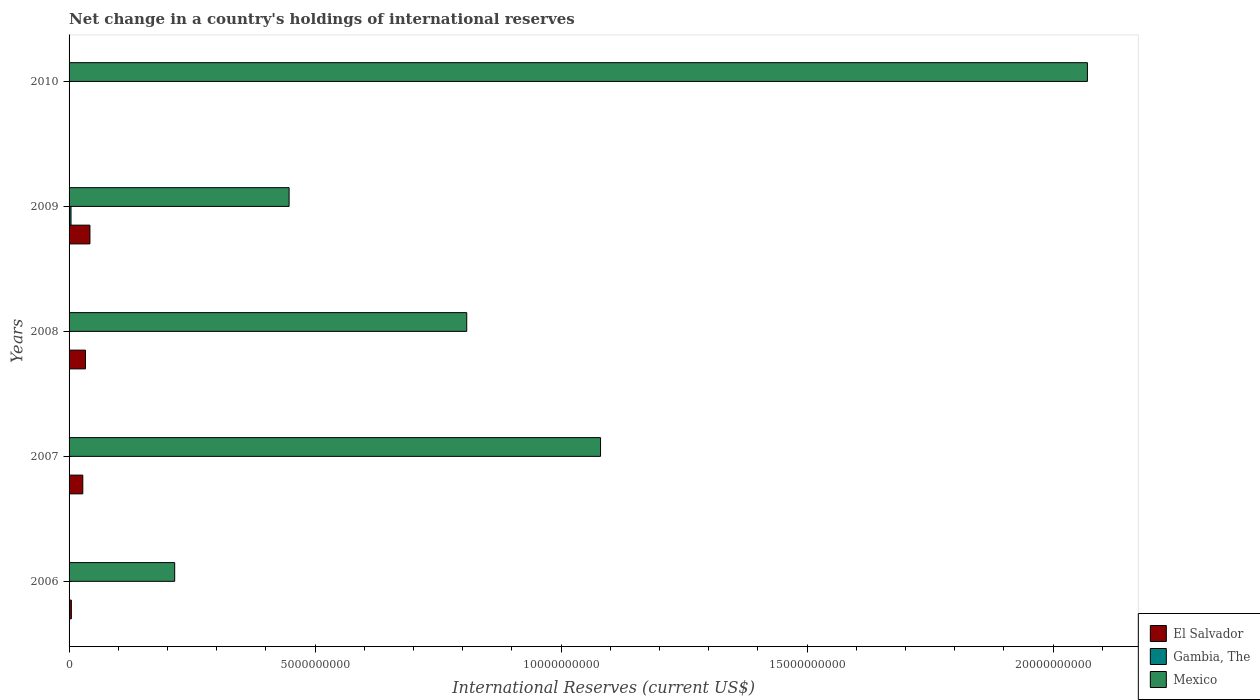Are the number of bars per tick equal to the number of legend labels?
Provide a short and direct response. No. What is the label of the 3rd group of bars from the top?
Ensure brevity in your answer.  2008. In how many cases, is the number of bars for a given year not equal to the number of legend labels?
Offer a terse response. 3. What is the international reserves in El Salvador in 2009?
Your response must be concise. 4.24e+08. Across all years, what is the maximum international reserves in El Salvador?
Your response must be concise. 4.24e+08. What is the total international reserves in Gambia, The in the graph?
Ensure brevity in your answer.  4.07e+07. What is the difference between the international reserves in Mexico in 2008 and that in 2009?
Ensure brevity in your answer.  3.61e+09. What is the difference between the international reserves in Mexico in 2010 and the international reserves in Gambia, The in 2009?
Give a very brief answer. 2.07e+1. What is the average international reserves in Mexico per year?
Offer a very short reply. 9.24e+09. In the year 2006, what is the difference between the international reserves in Gambia, The and international reserves in Mexico?
Provide a succinct answer. -2.15e+09. Is the international reserves in El Salvador in 2008 less than that in 2009?
Provide a succinct answer. Yes. What is the difference between the highest and the second highest international reserves in El Salvador?
Offer a very short reply. 9.07e+07. What is the difference between the highest and the lowest international reserves in El Salvador?
Offer a very short reply. 4.24e+08. Is the sum of the international reserves in Gambia, The in 2006 and 2009 greater than the maximum international reserves in Mexico across all years?
Ensure brevity in your answer.  No. Are all the bars in the graph horizontal?
Offer a very short reply. Yes. What is the difference between two consecutive major ticks on the X-axis?
Your answer should be very brief. 5.00e+09. Are the values on the major ticks of X-axis written in scientific E-notation?
Your answer should be very brief. No. Where does the legend appear in the graph?
Your answer should be very brief. Bottom right. What is the title of the graph?
Give a very brief answer. Net change in a country's holdings of international reserves. What is the label or title of the X-axis?
Your answer should be compact. International Reserves (current US$). What is the label or title of the Y-axis?
Your response must be concise. Years. What is the International Reserves (current US$) of El Salvador in 2006?
Provide a succinct answer. 4.66e+07. What is the International Reserves (current US$) in Gambia, The in 2006?
Your answer should be compact. 1.14e+06. What is the International Reserves (current US$) in Mexico in 2006?
Provide a succinct answer. 2.15e+09. What is the International Reserves (current US$) in El Salvador in 2007?
Offer a terse response. 2.79e+08. What is the International Reserves (current US$) in Gambia, The in 2007?
Provide a short and direct response. 0. What is the International Reserves (current US$) in Mexico in 2007?
Ensure brevity in your answer.  1.08e+1. What is the International Reserves (current US$) in El Salvador in 2008?
Keep it short and to the point. 3.33e+08. What is the International Reserves (current US$) of Gambia, The in 2008?
Your answer should be very brief. 0. What is the International Reserves (current US$) in Mexico in 2008?
Give a very brief answer. 8.08e+09. What is the International Reserves (current US$) in El Salvador in 2009?
Offer a very short reply. 4.24e+08. What is the International Reserves (current US$) of Gambia, The in 2009?
Offer a very short reply. 3.96e+07. What is the International Reserves (current US$) in Mexico in 2009?
Your answer should be compact. 4.47e+09. What is the International Reserves (current US$) of Gambia, The in 2010?
Give a very brief answer. 0. What is the International Reserves (current US$) in Mexico in 2010?
Keep it short and to the point. 2.07e+1. Across all years, what is the maximum International Reserves (current US$) of El Salvador?
Ensure brevity in your answer.  4.24e+08. Across all years, what is the maximum International Reserves (current US$) in Gambia, The?
Your answer should be compact. 3.96e+07. Across all years, what is the maximum International Reserves (current US$) of Mexico?
Provide a succinct answer. 2.07e+1. Across all years, what is the minimum International Reserves (current US$) of El Salvador?
Provide a succinct answer. 0. Across all years, what is the minimum International Reserves (current US$) of Gambia, The?
Ensure brevity in your answer.  0. Across all years, what is the minimum International Reserves (current US$) of Mexico?
Your answer should be very brief. 2.15e+09. What is the total International Reserves (current US$) in El Salvador in the graph?
Your answer should be very brief. 1.08e+09. What is the total International Reserves (current US$) in Gambia, The in the graph?
Provide a succinct answer. 4.07e+07. What is the total International Reserves (current US$) of Mexico in the graph?
Make the answer very short. 4.62e+1. What is the difference between the International Reserves (current US$) in El Salvador in 2006 and that in 2007?
Provide a short and direct response. -2.32e+08. What is the difference between the International Reserves (current US$) in Mexico in 2006 and that in 2007?
Provide a short and direct response. -8.66e+09. What is the difference between the International Reserves (current US$) of El Salvador in 2006 and that in 2008?
Give a very brief answer. -2.87e+08. What is the difference between the International Reserves (current US$) of Mexico in 2006 and that in 2008?
Your answer should be very brief. -5.94e+09. What is the difference between the International Reserves (current US$) of El Salvador in 2006 and that in 2009?
Keep it short and to the point. -3.78e+08. What is the difference between the International Reserves (current US$) of Gambia, The in 2006 and that in 2009?
Ensure brevity in your answer.  -3.85e+07. What is the difference between the International Reserves (current US$) in Mexico in 2006 and that in 2009?
Provide a succinct answer. -2.33e+09. What is the difference between the International Reserves (current US$) in Mexico in 2006 and that in 2010?
Offer a terse response. -1.86e+1. What is the difference between the International Reserves (current US$) in El Salvador in 2007 and that in 2008?
Your answer should be very brief. -5.45e+07. What is the difference between the International Reserves (current US$) of Mexico in 2007 and that in 2008?
Provide a short and direct response. 2.72e+09. What is the difference between the International Reserves (current US$) of El Salvador in 2007 and that in 2009?
Provide a short and direct response. -1.45e+08. What is the difference between the International Reserves (current US$) in Mexico in 2007 and that in 2009?
Keep it short and to the point. 6.33e+09. What is the difference between the International Reserves (current US$) of Mexico in 2007 and that in 2010?
Ensure brevity in your answer.  -9.90e+09. What is the difference between the International Reserves (current US$) of El Salvador in 2008 and that in 2009?
Ensure brevity in your answer.  -9.07e+07. What is the difference between the International Reserves (current US$) in Mexico in 2008 and that in 2009?
Your response must be concise. 3.61e+09. What is the difference between the International Reserves (current US$) in Mexico in 2008 and that in 2010?
Offer a terse response. -1.26e+1. What is the difference between the International Reserves (current US$) of Mexico in 2009 and that in 2010?
Your response must be concise. -1.62e+1. What is the difference between the International Reserves (current US$) in El Salvador in 2006 and the International Reserves (current US$) in Mexico in 2007?
Your answer should be compact. -1.08e+1. What is the difference between the International Reserves (current US$) in Gambia, The in 2006 and the International Reserves (current US$) in Mexico in 2007?
Your response must be concise. -1.08e+1. What is the difference between the International Reserves (current US$) of El Salvador in 2006 and the International Reserves (current US$) of Mexico in 2008?
Your answer should be very brief. -8.04e+09. What is the difference between the International Reserves (current US$) of Gambia, The in 2006 and the International Reserves (current US$) of Mexico in 2008?
Ensure brevity in your answer.  -8.08e+09. What is the difference between the International Reserves (current US$) in El Salvador in 2006 and the International Reserves (current US$) in Gambia, The in 2009?
Give a very brief answer. 7.02e+06. What is the difference between the International Reserves (current US$) in El Salvador in 2006 and the International Reserves (current US$) in Mexico in 2009?
Keep it short and to the point. -4.43e+09. What is the difference between the International Reserves (current US$) in Gambia, The in 2006 and the International Reserves (current US$) in Mexico in 2009?
Give a very brief answer. -4.47e+09. What is the difference between the International Reserves (current US$) in El Salvador in 2006 and the International Reserves (current US$) in Mexico in 2010?
Give a very brief answer. -2.07e+1. What is the difference between the International Reserves (current US$) in Gambia, The in 2006 and the International Reserves (current US$) in Mexico in 2010?
Your response must be concise. -2.07e+1. What is the difference between the International Reserves (current US$) of El Salvador in 2007 and the International Reserves (current US$) of Mexico in 2008?
Offer a terse response. -7.80e+09. What is the difference between the International Reserves (current US$) in El Salvador in 2007 and the International Reserves (current US$) in Gambia, The in 2009?
Ensure brevity in your answer.  2.39e+08. What is the difference between the International Reserves (current US$) of El Salvador in 2007 and the International Reserves (current US$) of Mexico in 2009?
Ensure brevity in your answer.  -4.19e+09. What is the difference between the International Reserves (current US$) of El Salvador in 2007 and the International Reserves (current US$) of Mexico in 2010?
Keep it short and to the point. -2.04e+1. What is the difference between the International Reserves (current US$) of El Salvador in 2008 and the International Reserves (current US$) of Gambia, The in 2009?
Your answer should be very brief. 2.94e+08. What is the difference between the International Reserves (current US$) of El Salvador in 2008 and the International Reserves (current US$) of Mexico in 2009?
Your answer should be very brief. -4.14e+09. What is the difference between the International Reserves (current US$) of El Salvador in 2008 and the International Reserves (current US$) of Mexico in 2010?
Keep it short and to the point. -2.04e+1. What is the difference between the International Reserves (current US$) in El Salvador in 2009 and the International Reserves (current US$) in Mexico in 2010?
Provide a short and direct response. -2.03e+1. What is the difference between the International Reserves (current US$) in Gambia, The in 2009 and the International Reserves (current US$) in Mexico in 2010?
Your response must be concise. -2.07e+1. What is the average International Reserves (current US$) in El Salvador per year?
Offer a terse response. 2.17e+08. What is the average International Reserves (current US$) in Gambia, The per year?
Provide a succinct answer. 8.15e+06. What is the average International Reserves (current US$) in Mexico per year?
Make the answer very short. 9.24e+09. In the year 2006, what is the difference between the International Reserves (current US$) in El Salvador and International Reserves (current US$) in Gambia, The?
Make the answer very short. 4.55e+07. In the year 2006, what is the difference between the International Reserves (current US$) of El Salvador and International Reserves (current US$) of Mexico?
Your answer should be compact. -2.10e+09. In the year 2006, what is the difference between the International Reserves (current US$) in Gambia, The and International Reserves (current US$) in Mexico?
Give a very brief answer. -2.15e+09. In the year 2007, what is the difference between the International Reserves (current US$) in El Salvador and International Reserves (current US$) in Mexico?
Provide a succinct answer. -1.05e+1. In the year 2008, what is the difference between the International Reserves (current US$) in El Salvador and International Reserves (current US$) in Mexico?
Offer a very short reply. -7.75e+09. In the year 2009, what is the difference between the International Reserves (current US$) in El Salvador and International Reserves (current US$) in Gambia, The?
Offer a very short reply. 3.85e+08. In the year 2009, what is the difference between the International Reserves (current US$) in El Salvador and International Reserves (current US$) in Mexico?
Ensure brevity in your answer.  -4.05e+09. In the year 2009, what is the difference between the International Reserves (current US$) of Gambia, The and International Reserves (current US$) of Mexico?
Provide a short and direct response. -4.43e+09. What is the ratio of the International Reserves (current US$) in El Salvador in 2006 to that in 2007?
Ensure brevity in your answer.  0.17. What is the ratio of the International Reserves (current US$) in Mexico in 2006 to that in 2007?
Your answer should be compact. 0.2. What is the ratio of the International Reserves (current US$) of El Salvador in 2006 to that in 2008?
Your response must be concise. 0.14. What is the ratio of the International Reserves (current US$) of Mexico in 2006 to that in 2008?
Your answer should be compact. 0.27. What is the ratio of the International Reserves (current US$) in El Salvador in 2006 to that in 2009?
Provide a succinct answer. 0.11. What is the ratio of the International Reserves (current US$) in Gambia, The in 2006 to that in 2009?
Your answer should be very brief. 0.03. What is the ratio of the International Reserves (current US$) in Mexico in 2006 to that in 2009?
Your response must be concise. 0.48. What is the ratio of the International Reserves (current US$) of Mexico in 2006 to that in 2010?
Keep it short and to the point. 0.1. What is the ratio of the International Reserves (current US$) in El Salvador in 2007 to that in 2008?
Make the answer very short. 0.84. What is the ratio of the International Reserves (current US$) in Mexico in 2007 to that in 2008?
Make the answer very short. 1.34. What is the ratio of the International Reserves (current US$) of El Salvador in 2007 to that in 2009?
Ensure brevity in your answer.  0.66. What is the ratio of the International Reserves (current US$) in Mexico in 2007 to that in 2009?
Your answer should be compact. 2.42. What is the ratio of the International Reserves (current US$) of Mexico in 2007 to that in 2010?
Make the answer very short. 0.52. What is the ratio of the International Reserves (current US$) in El Salvador in 2008 to that in 2009?
Your answer should be very brief. 0.79. What is the ratio of the International Reserves (current US$) in Mexico in 2008 to that in 2009?
Your answer should be very brief. 1.81. What is the ratio of the International Reserves (current US$) of Mexico in 2008 to that in 2010?
Provide a succinct answer. 0.39. What is the ratio of the International Reserves (current US$) in Mexico in 2009 to that in 2010?
Make the answer very short. 0.22. What is the difference between the highest and the second highest International Reserves (current US$) in El Salvador?
Your answer should be compact. 9.07e+07. What is the difference between the highest and the second highest International Reserves (current US$) in Mexico?
Offer a very short reply. 9.90e+09. What is the difference between the highest and the lowest International Reserves (current US$) of El Salvador?
Provide a short and direct response. 4.24e+08. What is the difference between the highest and the lowest International Reserves (current US$) of Gambia, The?
Give a very brief answer. 3.96e+07. What is the difference between the highest and the lowest International Reserves (current US$) in Mexico?
Provide a succinct answer. 1.86e+1. 